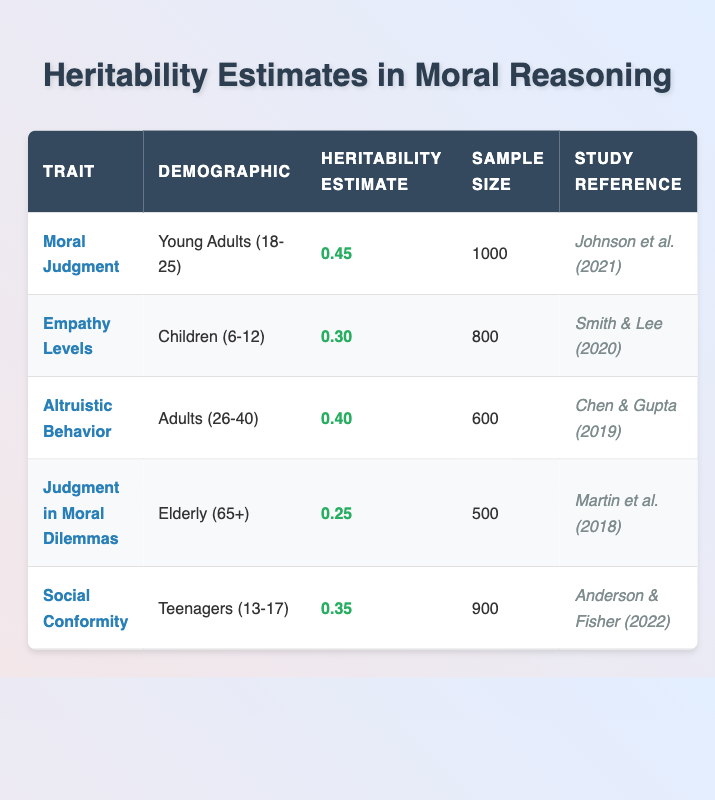What is the heritability estimate for Moral Judgment in Young Adults? The table shows that the heritability estimate for Moral Judgment in the demographic of Young Adults (18-25) is listed under the corresponding traits and demographics.
Answer: 0.45 How many participants were involved in the study for Empathy Levels in Children? The table indicates that the sample size for the Empathy Levels trait in Children (6-12) is explicitly mentioned.
Answer: 800 Which trait has the highest heritability estimate and what is its value? To find the highest heritability estimate, assess the values listed for each trait. The highest value among the listed heritability estimates is 0.45, corresponding to the trait Moral Judgment for Young Adults (18-25).
Answer: Moral Judgment, 0.45 Is the heritability estimate for Judgment in Moral Dilemmas in the Elderly demographic lower than 0.30? The heritability estimate for Judgment in Moral Dilemmas for the Elderly (65+) demographic is 0.25. Since 0.25 is less than 0.30, the statement is true.
Answer: Yes What is the average heritability estimate for traits associated with moral reasoning in the table? First, sum all heritability estimates: 0.45 + 0.30 + 0.40 + 0.25 + 0.35 = 1.75. There are 5 traits, so the average heritability estimate is calculated as 1.75 / 5 = 0.35.
Answer: 0.35 Which demographic has the lowest heritability estimate, and what is the trait associated with it? Review the heritability estimates across demographics to identify the lowest. The lowest value is 0.25, associated with the trait Judgment in Moral Dilemmas for the Elderly (65+).
Answer: Elderly (65+), Judgment in Moral Dilemmas How many more participants were included in the study of Moral Judgment compared to Judgment in Moral Dilemmas? The sample size for Moral Judgment is 1000, while Judgment in Moral Dilemmas has 500 participants. Subtracting these values gives 1000 - 500 = 500 participants more.
Answer: 500 Is it true that Altruistic Behavior in Adults (26-40) has a higher heritability estimate than Empathy Levels in Children (6-12)? The heritability estimate for Altruistic Behavior is 0.40, while for Empathy Levels it is 0.30. Since 0.40 is greater than 0.30, the statement is true.
Answer: Yes What is the difference in heritability estimates between Social Conformity and Empathy Levels? The heritability estimate for Social Conformity is 0.35, and for Empathy Levels, it is 0.30. The difference is calculated as 0.35 - 0.30 = 0.05.
Answer: 0.05 